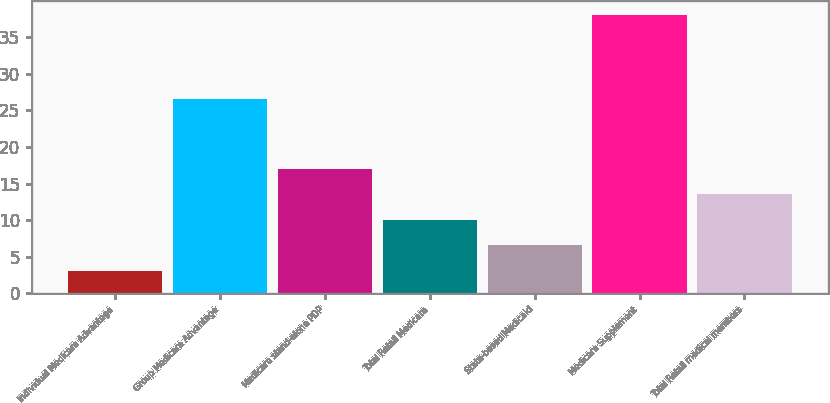<chart> <loc_0><loc_0><loc_500><loc_500><bar_chart><fcel>Individual Medicare Advantage<fcel>Group Medicare Advantage<fcel>Medicare stand-alone PDP<fcel>Total Retail Medicare<fcel>State-based Medicaid<fcel>Medicare Supplement<fcel>Total Retail medical members<nl><fcel>3.1<fcel>26.6<fcel>17.06<fcel>10.08<fcel>6.59<fcel>38<fcel>13.57<nl></chart> 